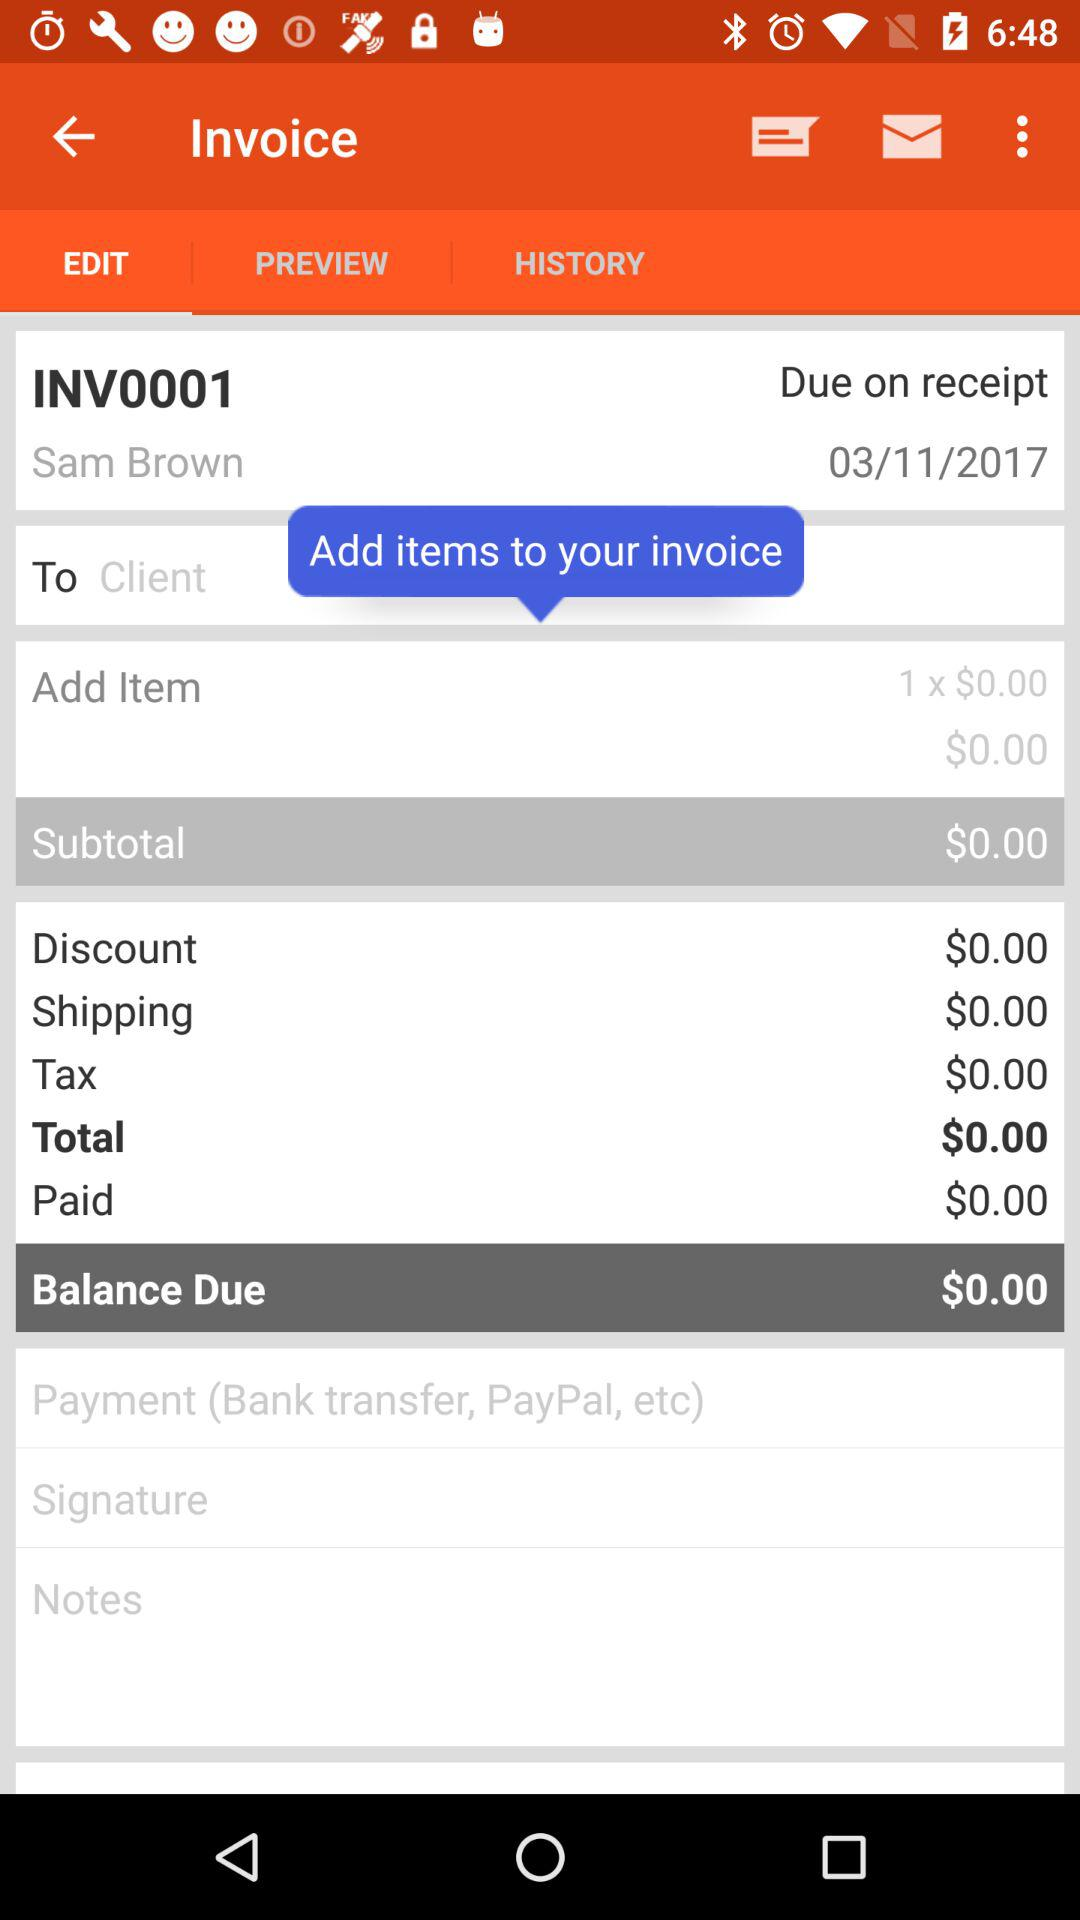What is the selected option? The selected option is "EDIT". 